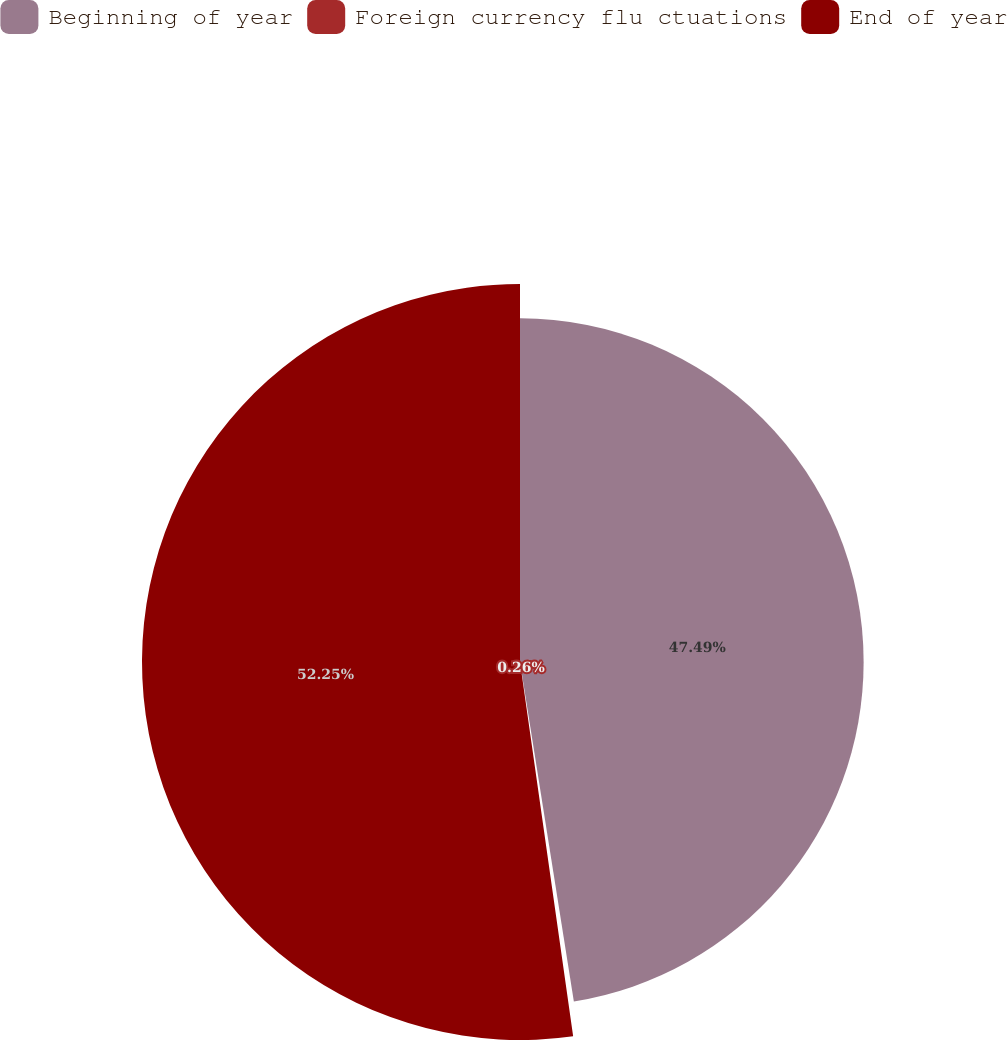Convert chart to OTSL. <chart><loc_0><loc_0><loc_500><loc_500><pie_chart><fcel>Beginning of year<fcel>Foreign currency flu ctuations<fcel>End of year<nl><fcel>47.49%<fcel>0.26%<fcel>52.24%<nl></chart> 